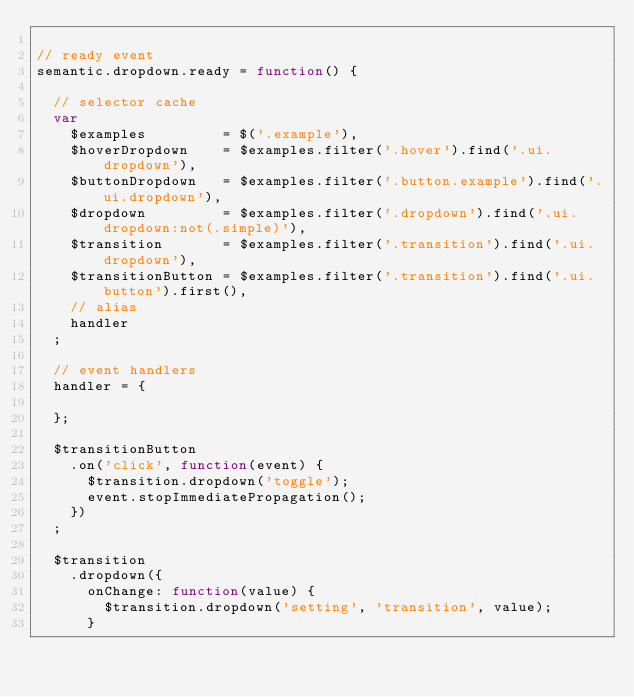<code> <loc_0><loc_0><loc_500><loc_500><_JavaScript_>
// ready event
semantic.dropdown.ready = function() {

  // selector cache
  var
    $examples         = $('.example'),
    $hoverDropdown    = $examples.filter('.hover').find('.ui.dropdown'),
    $buttonDropdown   = $examples.filter('.button.example').find('.ui.dropdown'),
    $dropdown         = $examples.filter('.dropdown').find('.ui.dropdown:not(.simple)'),
    $transition       = $examples.filter('.transition').find('.ui.dropdown'),
    $transitionButton = $examples.filter('.transition').find('.ui.button').first(),
    // alias
    handler
  ;

  // event handlers
  handler = {

  };

  $transitionButton
    .on('click', function(event) {
      $transition.dropdown('toggle');
      event.stopImmediatePropagation();
    })
  ;

  $transition
    .dropdown({
      onChange: function(value) {
        $transition.dropdown('setting', 'transition', value);
      }</code> 